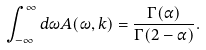Convert formula to latex. <formula><loc_0><loc_0><loc_500><loc_500>\int _ { - \infty } ^ { \infty } d \omega A ( \omega , { k } ) = \frac { \Gamma ( \alpha ) } { \Gamma ( 2 - \alpha ) } .</formula> 